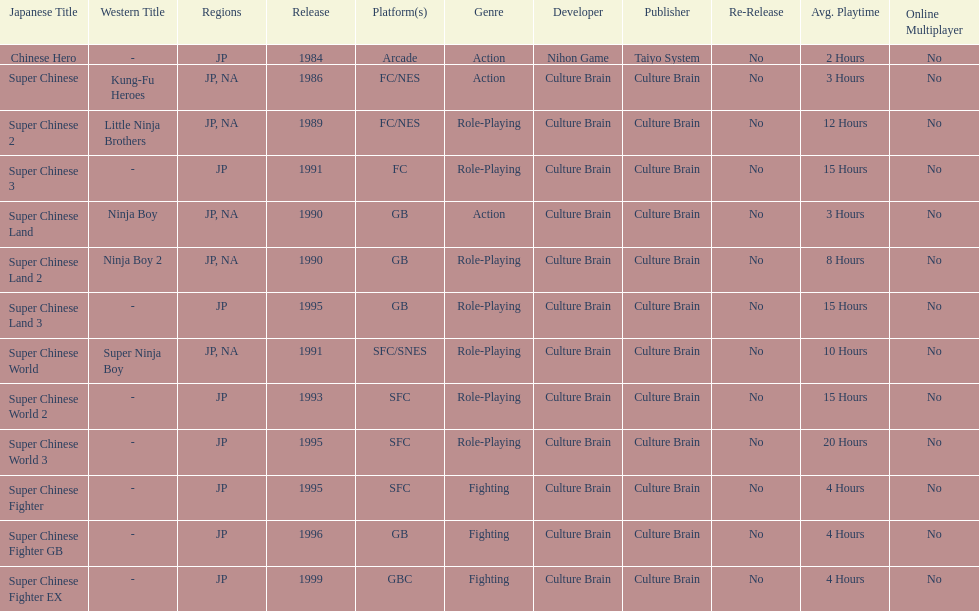Of the titles released in north america, which had the least releases? Super Chinese World. 